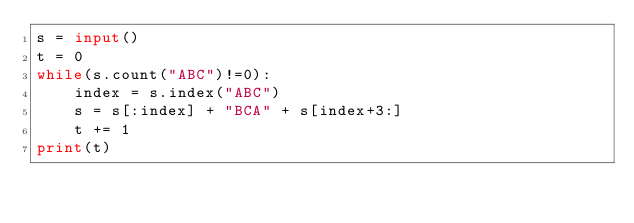Convert code to text. <code><loc_0><loc_0><loc_500><loc_500><_Python_>s = input()
t = 0
while(s.count("ABC")!=0):
    index = s.index("ABC")
    s = s[:index] + "BCA" + s[index+3:]
    t += 1
print(t)</code> 